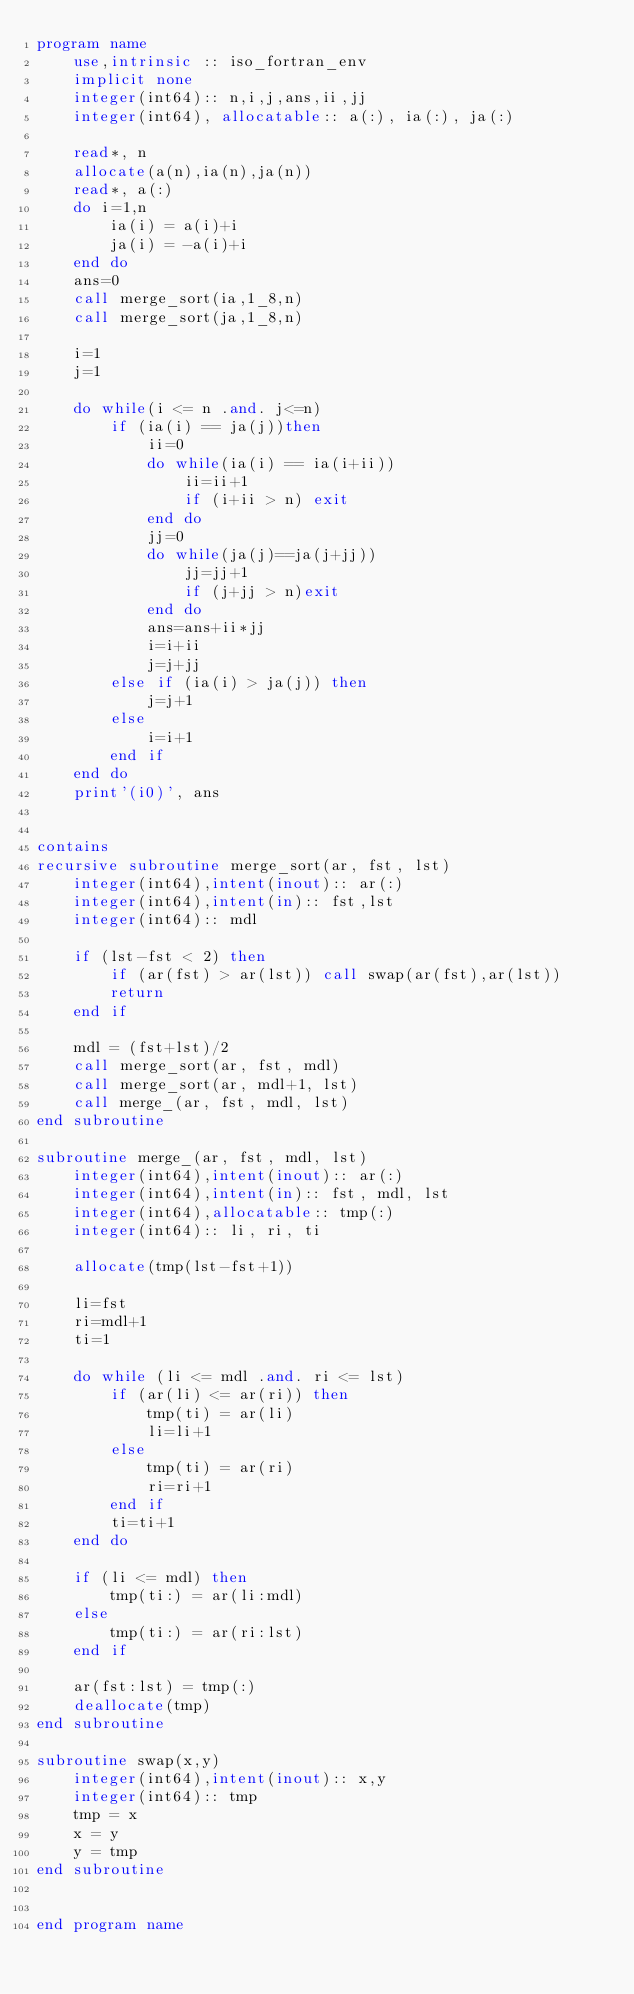Convert code to text. <code><loc_0><loc_0><loc_500><loc_500><_FORTRAN_>program name
    use,intrinsic :: iso_fortran_env
    implicit none
    integer(int64):: n,i,j,ans,ii,jj
    integer(int64), allocatable:: a(:), ia(:), ja(:)

    read*, n
    allocate(a(n),ia(n),ja(n))
    read*, a(:)
    do i=1,n
        ia(i) = a(i)+i
        ja(i) = -a(i)+i
    end do
    ans=0
    call merge_sort(ia,1_8,n)
    call merge_sort(ja,1_8,n)

    i=1
    j=1

    do while(i <= n .and. j<=n)
        if (ia(i) == ja(j))then
            ii=0
            do while(ia(i) == ia(i+ii))
                ii=ii+1
                if (i+ii > n) exit
            end do
            jj=0
            do while(ja(j)==ja(j+jj))
                jj=jj+1
                if (j+jj > n)exit
            end do
            ans=ans+ii*jj
            i=i+ii
            j=j+jj
        else if (ia(i) > ja(j)) then
            j=j+1
        else
            i=i+1
        end if
    end do
    print'(i0)', ans


contains
recursive subroutine merge_sort(ar, fst, lst)
    integer(int64),intent(inout):: ar(:)
    integer(int64),intent(in):: fst,lst
    integer(int64):: mdl

    if (lst-fst < 2) then
        if (ar(fst) > ar(lst)) call swap(ar(fst),ar(lst))
        return
    end if

    mdl = (fst+lst)/2
    call merge_sort(ar, fst, mdl)
    call merge_sort(ar, mdl+1, lst)
    call merge_(ar, fst, mdl, lst)
end subroutine

subroutine merge_(ar, fst, mdl, lst)
    integer(int64),intent(inout):: ar(:)
    integer(int64),intent(in):: fst, mdl, lst
    integer(int64),allocatable:: tmp(:)
    integer(int64):: li, ri, ti

    allocate(tmp(lst-fst+1))

    li=fst
    ri=mdl+1   
    ti=1

    do while (li <= mdl .and. ri <= lst)
        if (ar(li) <= ar(ri)) then
            tmp(ti) = ar(li)
            li=li+1
        else
            tmp(ti) = ar(ri)
            ri=ri+1
        end if
        ti=ti+1
    end do

    if (li <= mdl) then
        tmp(ti:) = ar(li:mdl)
    else
        tmp(ti:) = ar(ri:lst)
    end if

    ar(fst:lst) = tmp(:)
    deallocate(tmp)
end subroutine

subroutine swap(x,y)
    integer(int64),intent(inout):: x,y
    integer(int64):: tmp
    tmp = x
    x = y
    y = tmp
end subroutine
    

end program name</code> 